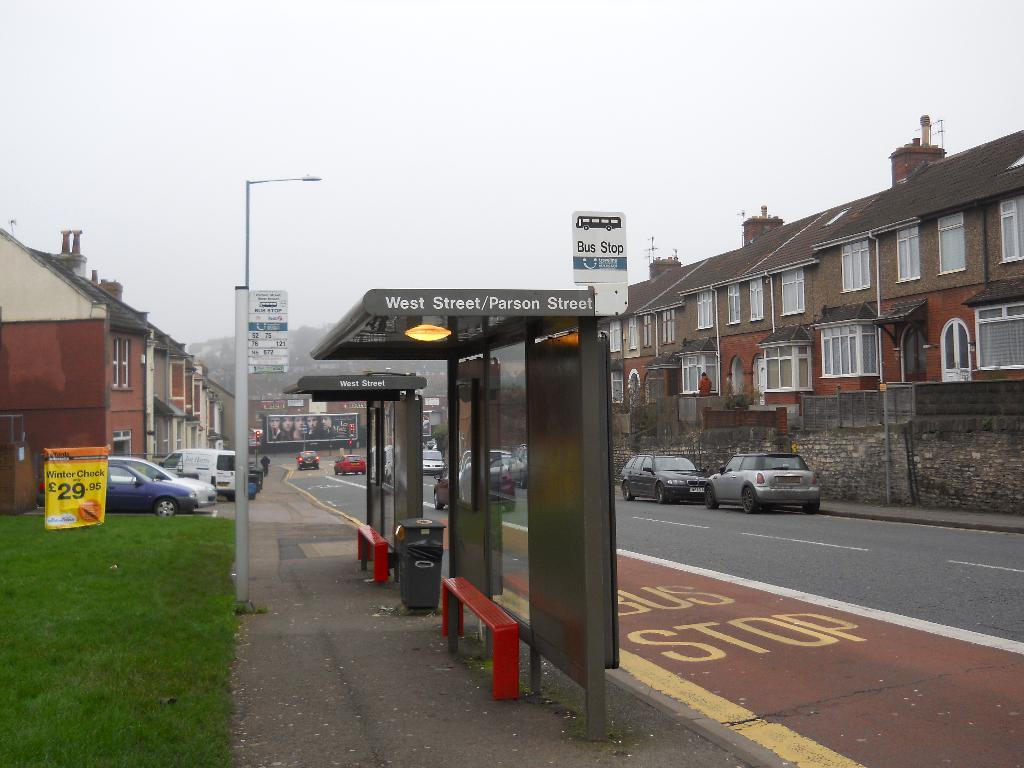<image>
Offer a succinct explanation of the picture presented. A West street/Parson street bus stop on a cloudy day 